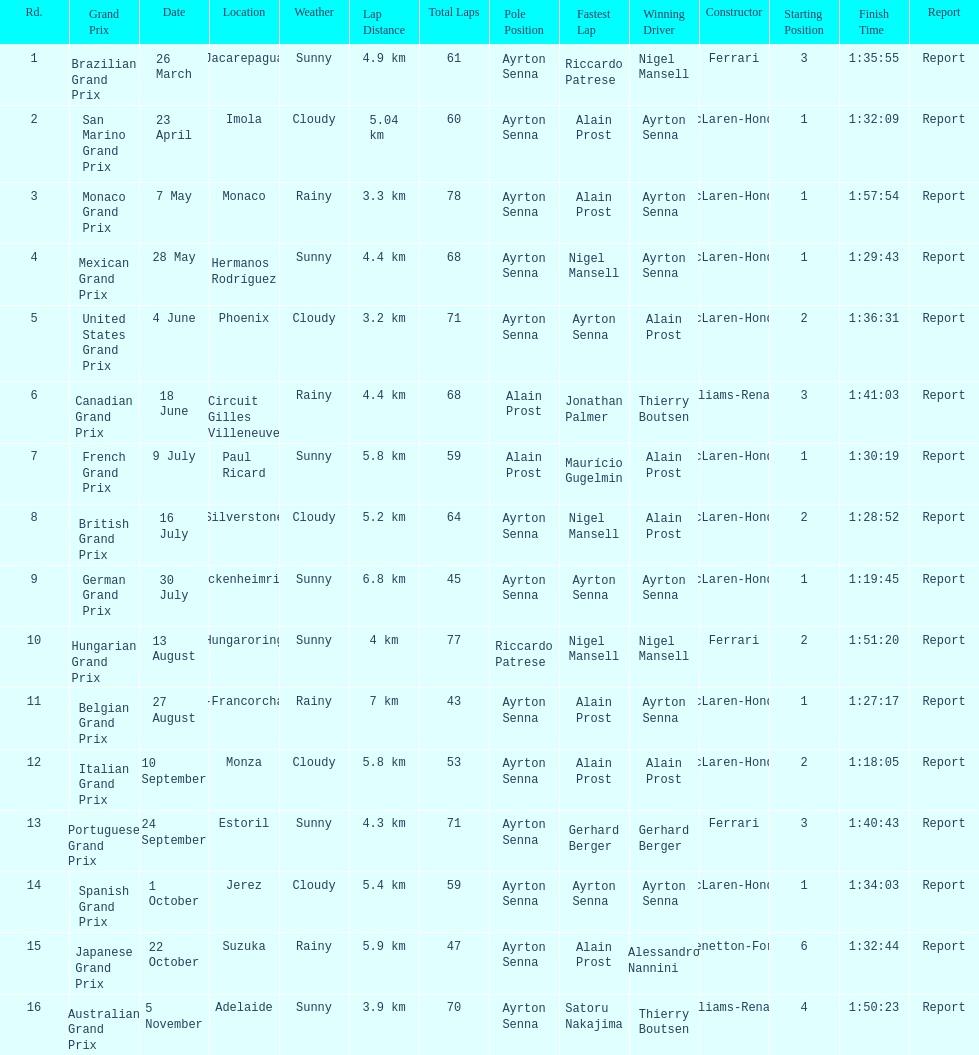What grand prix was before the san marino grand prix? Brazilian Grand Prix. 